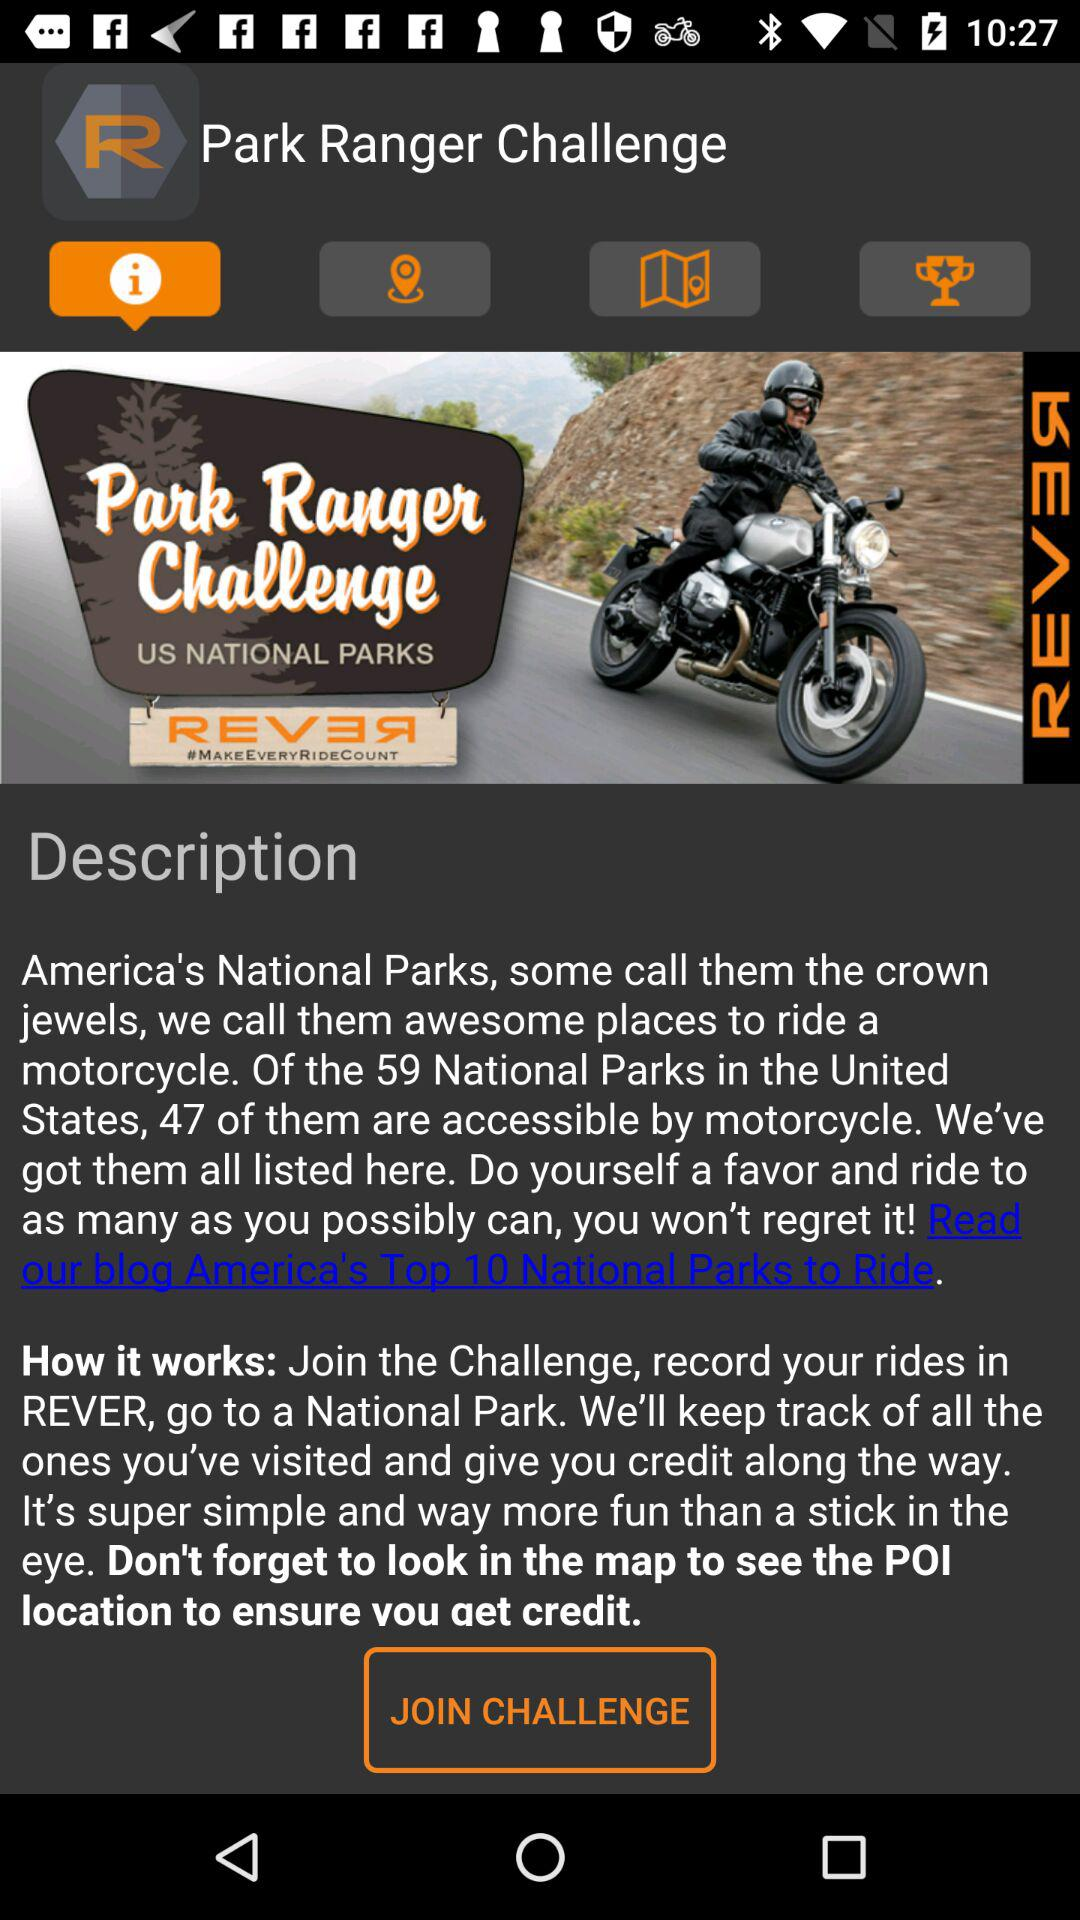Which tab has been selected? The tab that has been selected is "Information". 